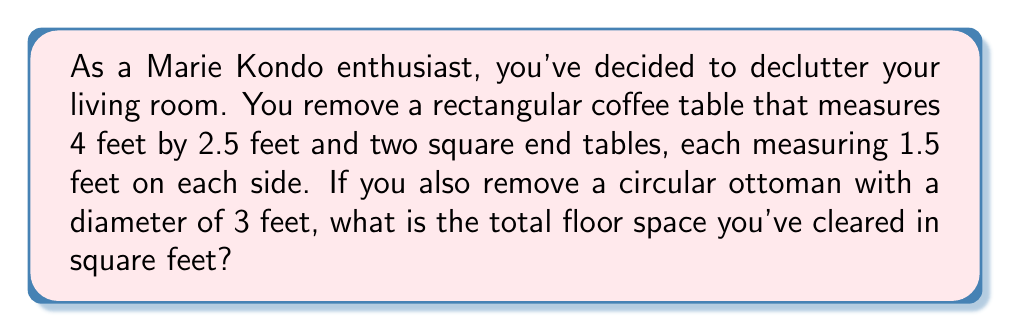Can you answer this question? Let's break this down step-by-step:

1. Calculate the area of the rectangular coffee table:
   $A_{coffee} = l \times w = 4 \text{ ft} \times 2.5 \text{ ft} = 10 \text{ sq ft}$

2. Calculate the area of each square end table:
   $A_{end} = s^2 = 1.5 \text{ ft} \times 1.5 \text{ ft} = 2.25 \text{ sq ft}$
   Since there are two end tables, the total area is:
   $A_{total\_end} = 2 \times 2.25 \text{ sq ft} = 4.5 \text{ sq ft}$

3. Calculate the area of the circular ottoman:
   $A_{ottoman} = \pi r^2$
   The diameter is 3 feet, so the radius is 1.5 feet.
   $A_{ottoman} = \pi (1.5 \text{ ft})^2 = 2.25\pi \text{ sq ft} \approx 7.07 \text{ sq ft}$

4. Sum up all the areas:
   $A_{total} = A_{coffee} + A_{total\_end} + A_{ottoman}$
   $A_{total} = 10 \text{ sq ft} + 4.5 \text{ sq ft} + 7.07 \text{ sq ft} = 21.57 \text{ sq ft}$

Therefore, the total floor space cleared is approximately 21.57 square feet.
Answer: $21.57 \text{ sq ft}$ 